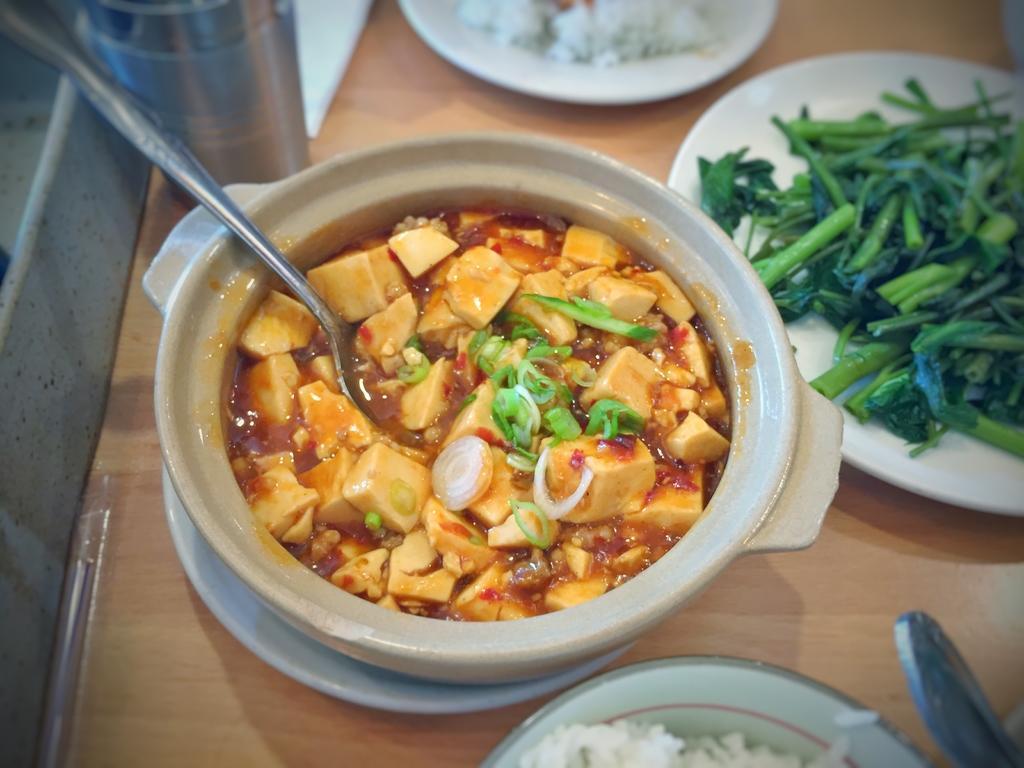How would you summarize this image in a sentence or two? In the center of the image there are food items in bowls and plates on the table. There is a glass. 